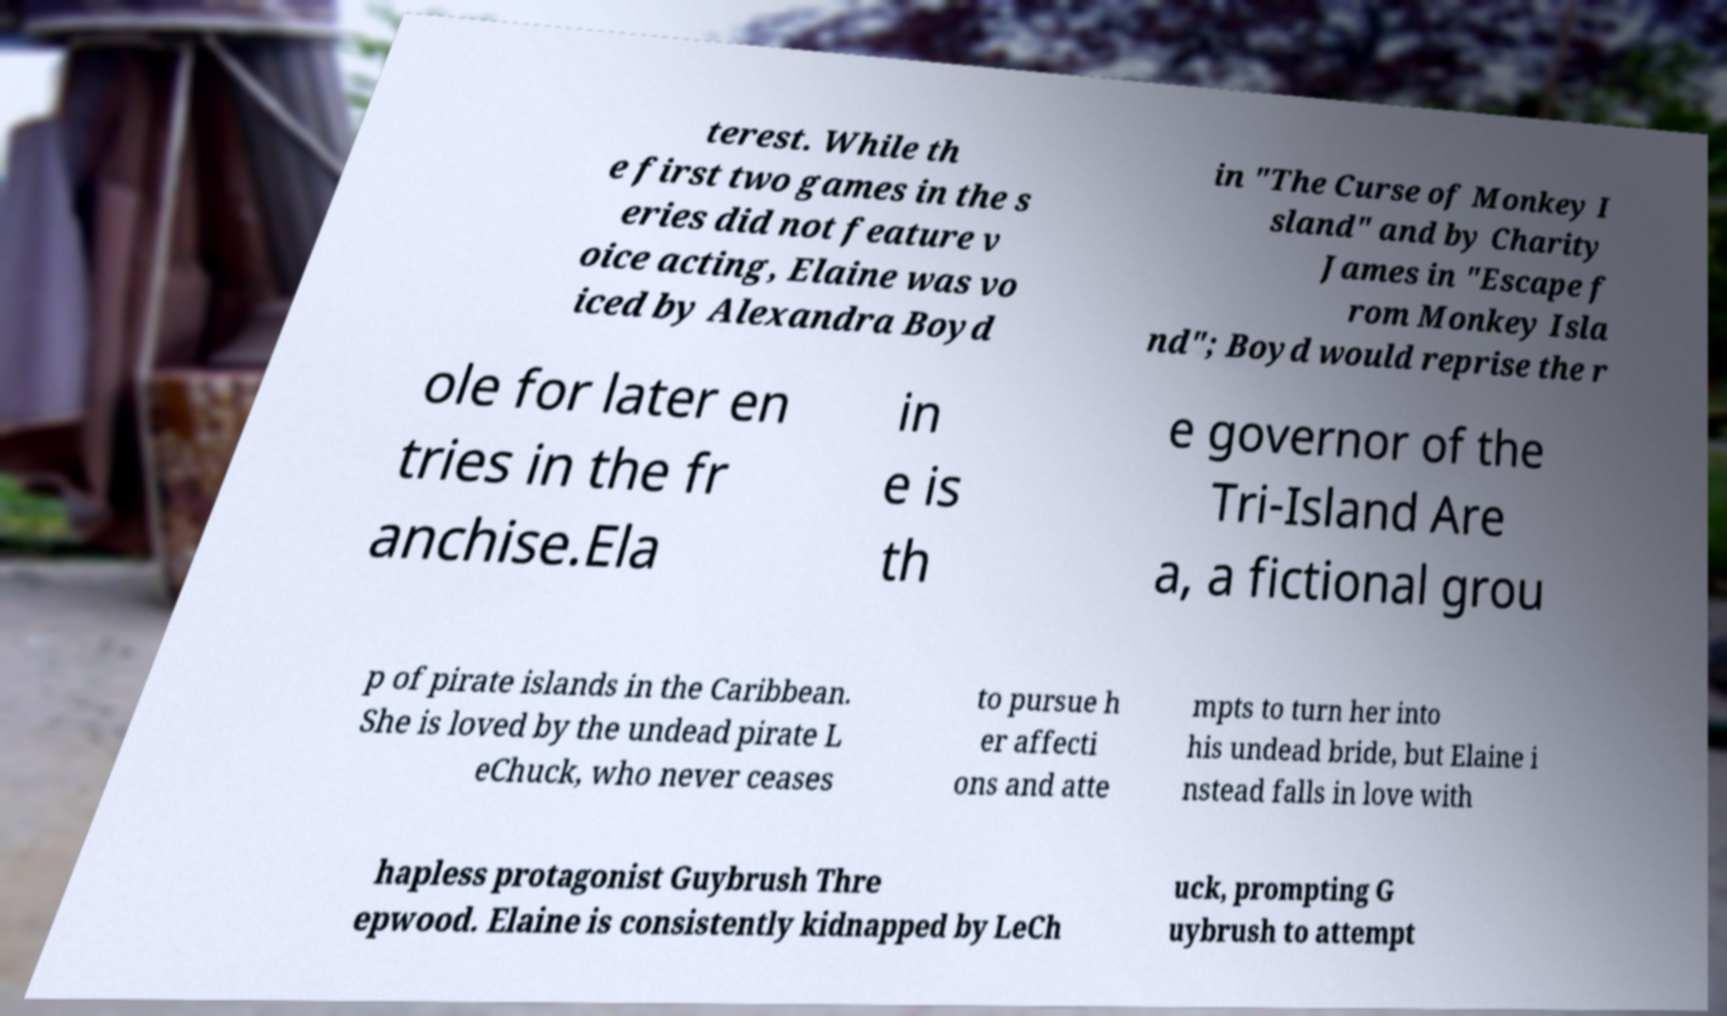There's text embedded in this image that I need extracted. Can you transcribe it verbatim? terest. While th e first two games in the s eries did not feature v oice acting, Elaine was vo iced by Alexandra Boyd in "The Curse of Monkey I sland" and by Charity James in "Escape f rom Monkey Isla nd"; Boyd would reprise the r ole for later en tries in the fr anchise.Ela in e is th e governor of the Tri-Island Are a, a fictional grou p of pirate islands in the Caribbean. She is loved by the undead pirate L eChuck, who never ceases to pursue h er affecti ons and atte mpts to turn her into his undead bride, but Elaine i nstead falls in love with hapless protagonist Guybrush Thre epwood. Elaine is consistently kidnapped by LeCh uck, prompting G uybrush to attempt 